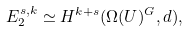Convert formula to latex. <formula><loc_0><loc_0><loc_500><loc_500>E _ { 2 } ^ { s , k } \simeq H ^ { k + s } ( \Omega ( U ) ^ { G } , d ) ,</formula> 